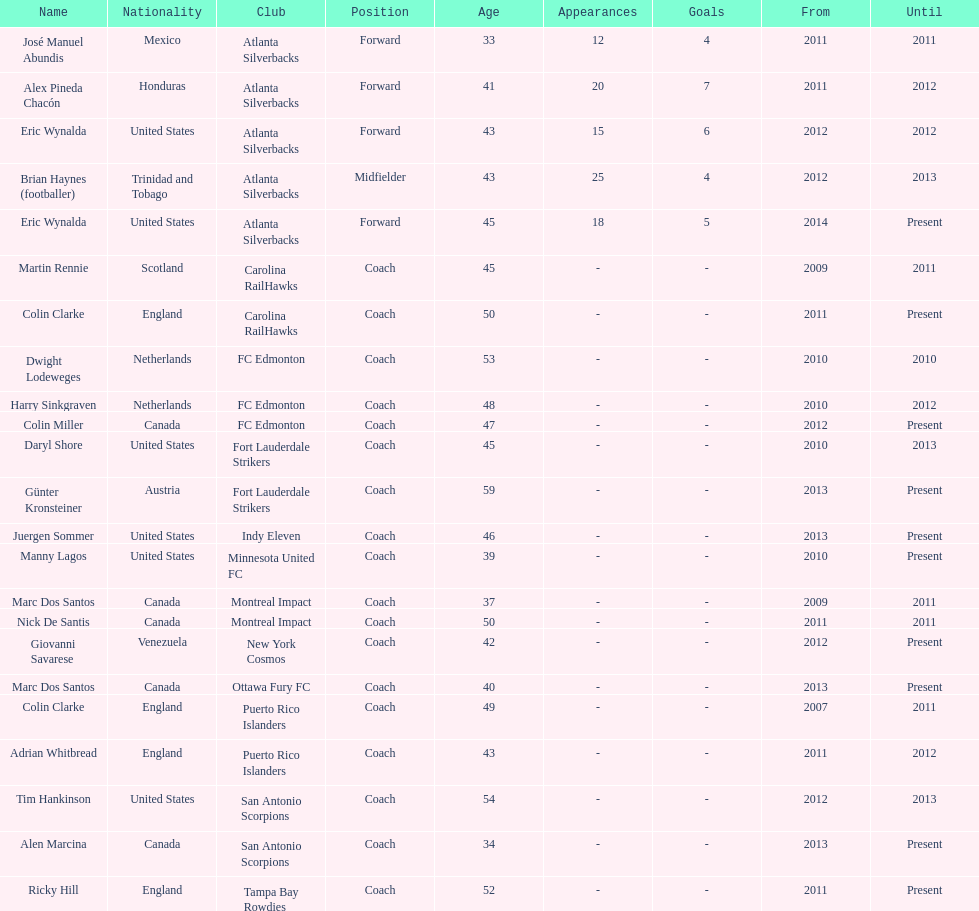Marc dos santos started as coach the same year as what other coach? Martin Rennie. 